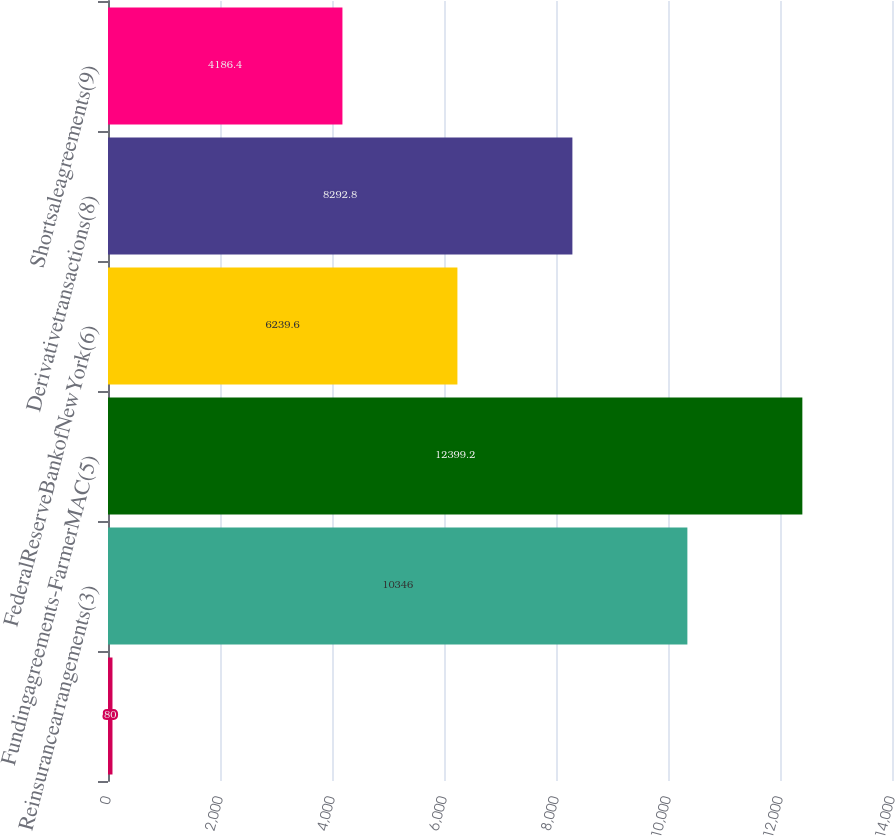Convert chart to OTSL. <chart><loc_0><loc_0><loc_500><loc_500><bar_chart><ecel><fcel>Reinsurancearrangements(3)<fcel>Fundingagreements-FarmerMAC(5)<fcel>FederalReserveBankofNewYork(6)<fcel>Derivativetransactions(8)<fcel>Shortsaleagreements(9)<nl><fcel>80<fcel>10346<fcel>12399.2<fcel>6239.6<fcel>8292.8<fcel>4186.4<nl></chart> 